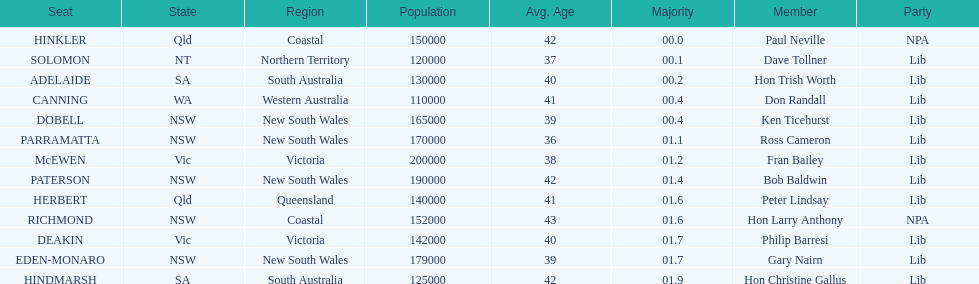What member comes next after hon trish worth? Don Randall. 